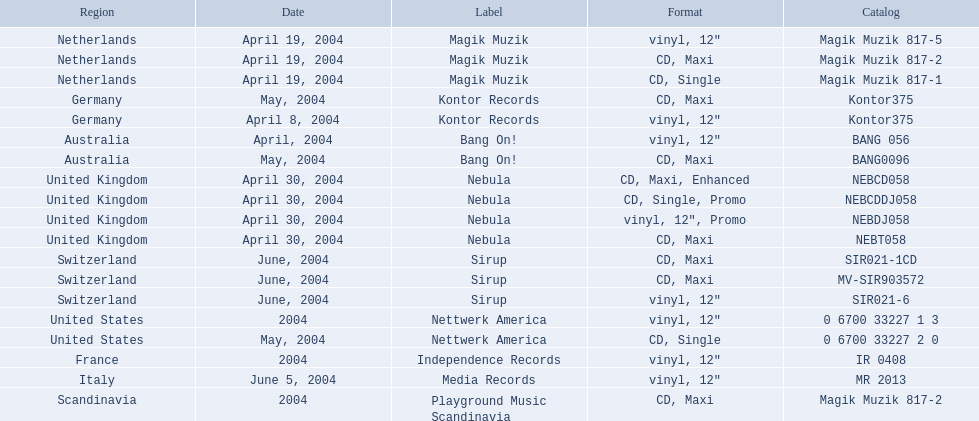What are the identifiers for "love comes again"? Magik Muzik, Magik Muzik, Magik Muzik, Kontor Records, Kontor Records, Bang On!, Bang On!, Nebula, Nebula, Nebula, Nebula, Sirup, Sirup, Sirup, Nettwerk America, Nettwerk America, Independence Records, Media Records, Playground Music Scandinavia. What label has been employed by the region of france? Independence Records. 